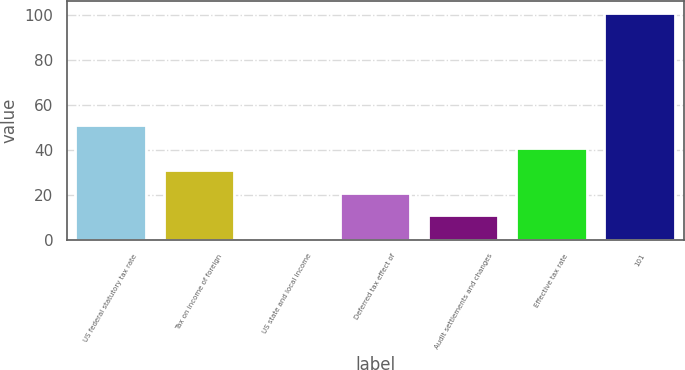Convert chart. <chart><loc_0><loc_0><loc_500><loc_500><bar_chart><fcel>US federal statutory tax rate<fcel>Tax on income of foreign<fcel>US state and local income<fcel>Deferred tax effect of<fcel>Audit settlements and changes<fcel>Effective tax rate<fcel>101<nl><fcel>50.9<fcel>30.86<fcel>0.8<fcel>20.84<fcel>10.82<fcel>40.88<fcel>101<nl></chart> 